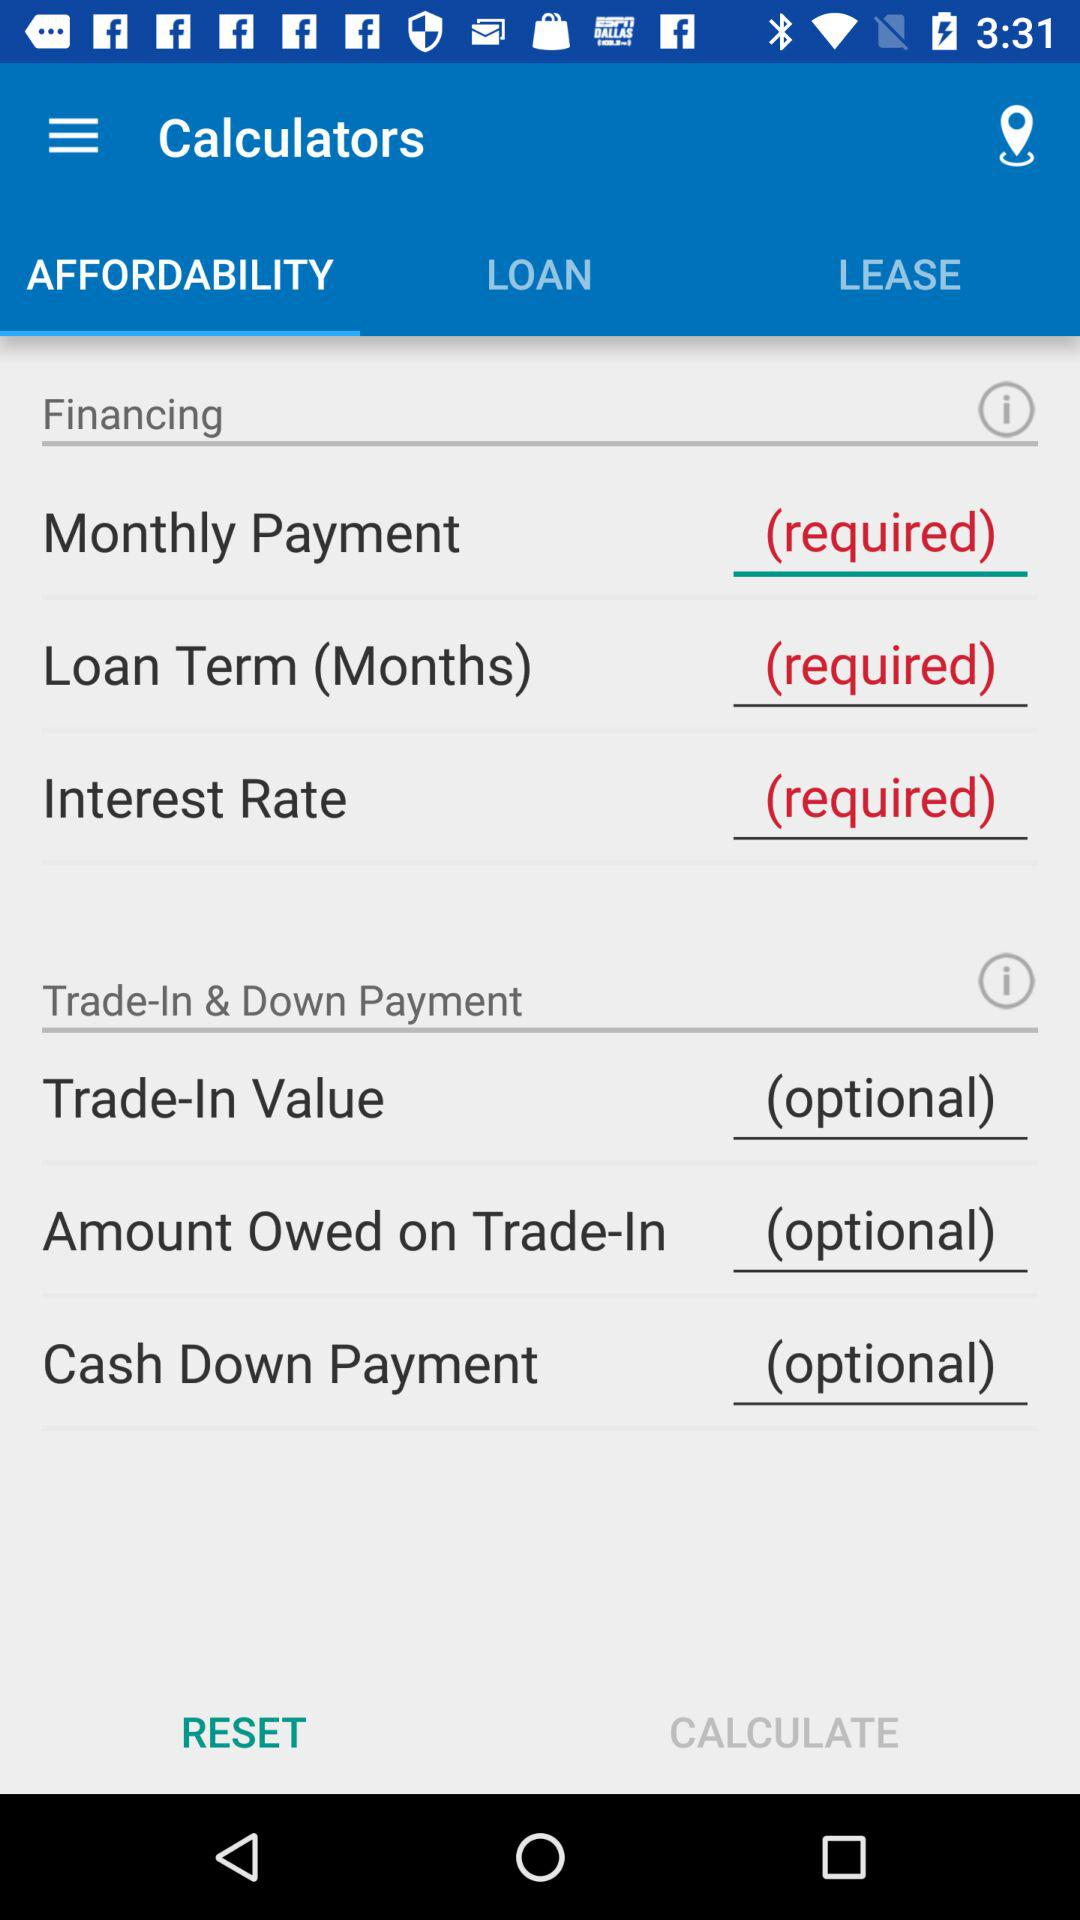What tab is selected? The selected tab is "AFFORDABILITY". 